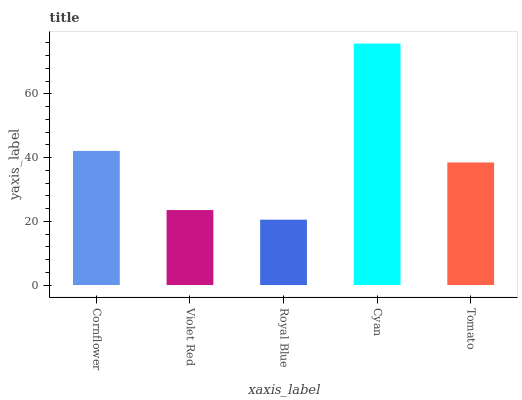Is Violet Red the minimum?
Answer yes or no. No. Is Violet Red the maximum?
Answer yes or no. No. Is Cornflower greater than Violet Red?
Answer yes or no. Yes. Is Violet Red less than Cornflower?
Answer yes or no. Yes. Is Violet Red greater than Cornflower?
Answer yes or no. No. Is Cornflower less than Violet Red?
Answer yes or no. No. Is Tomato the high median?
Answer yes or no. Yes. Is Tomato the low median?
Answer yes or no. Yes. Is Violet Red the high median?
Answer yes or no. No. Is Cornflower the low median?
Answer yes or no. No. 